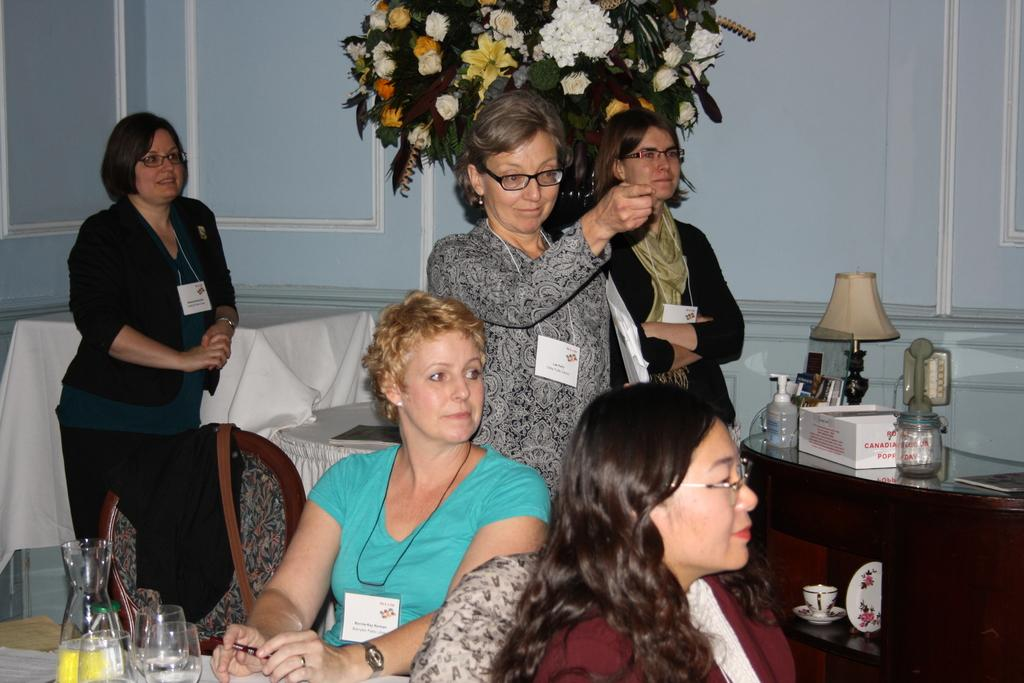Who or what can be seen in the image? There are people in the image. What is located on the table in the image? There are objects on a table in the image. What can be seen in the distance in the image? There is a wall and a tree in the background of the image. What type of wool is being used to create harmony in the image? There is no wool or reference to harmony in the image; it features people and objects on a table with a background of a wall and a tree. 